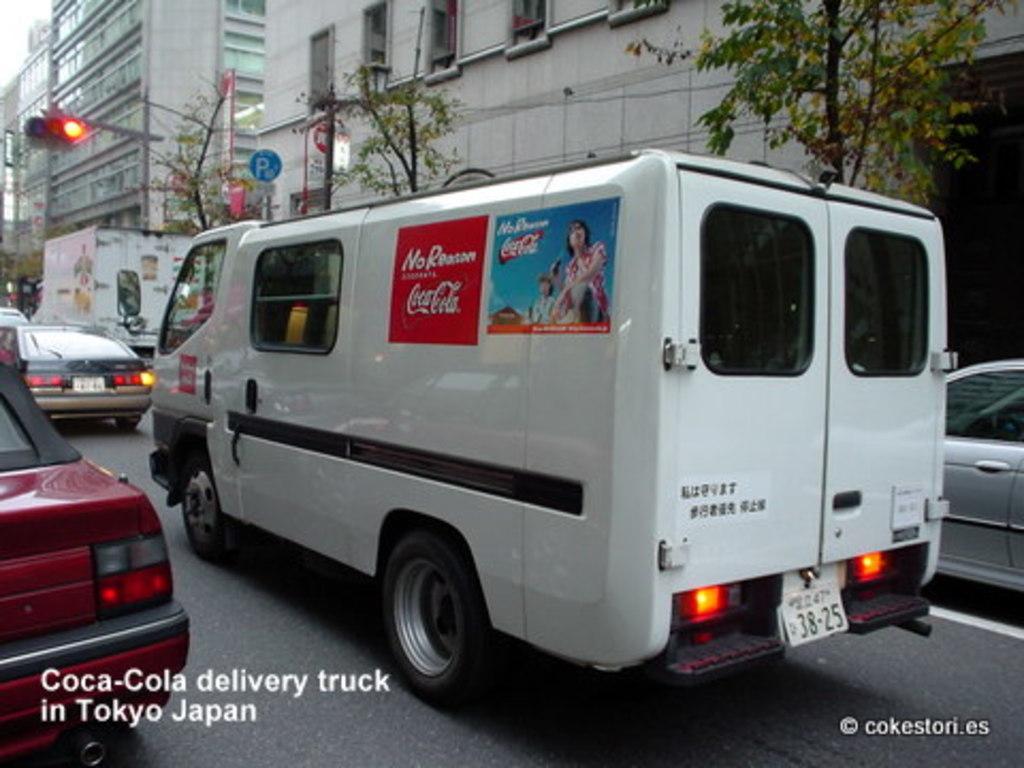What truck is that?
Your answer should be compact. Coca cola. What is the van's license plate number?
Offer a terse response. 38-25. 